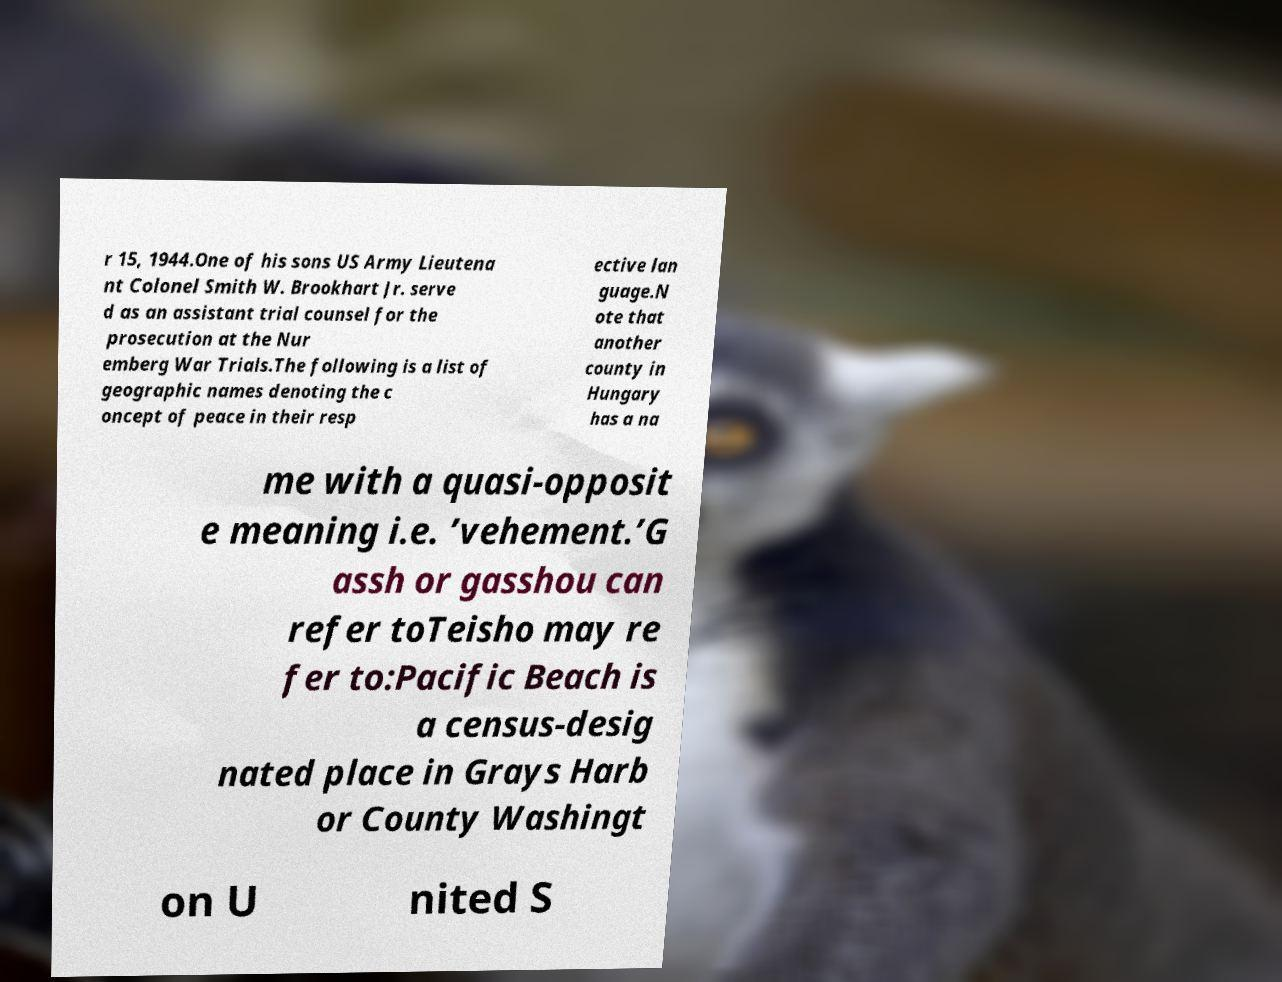Could you assist in decoding the text presented in this image and type it out clearly? r 15, 1944.One of his sons US Army Lieutena nt Colonel Smith W. Brookhart Jr. serve d as an assistant trial counsel for the prosecution at the Nur emberg War Trials.The following is a list of geographic names denoting the c oncept of peace in their resp ective lan guage.N ote that another county in Hungary has a na me with a quasi-opposit e meaning i.e. ’vehement.’G assh or gasshou can refer toTeisho may re fer to:Pacific Beach is a census-desig nated place in Grays Harb or County Washingt on U nited S 